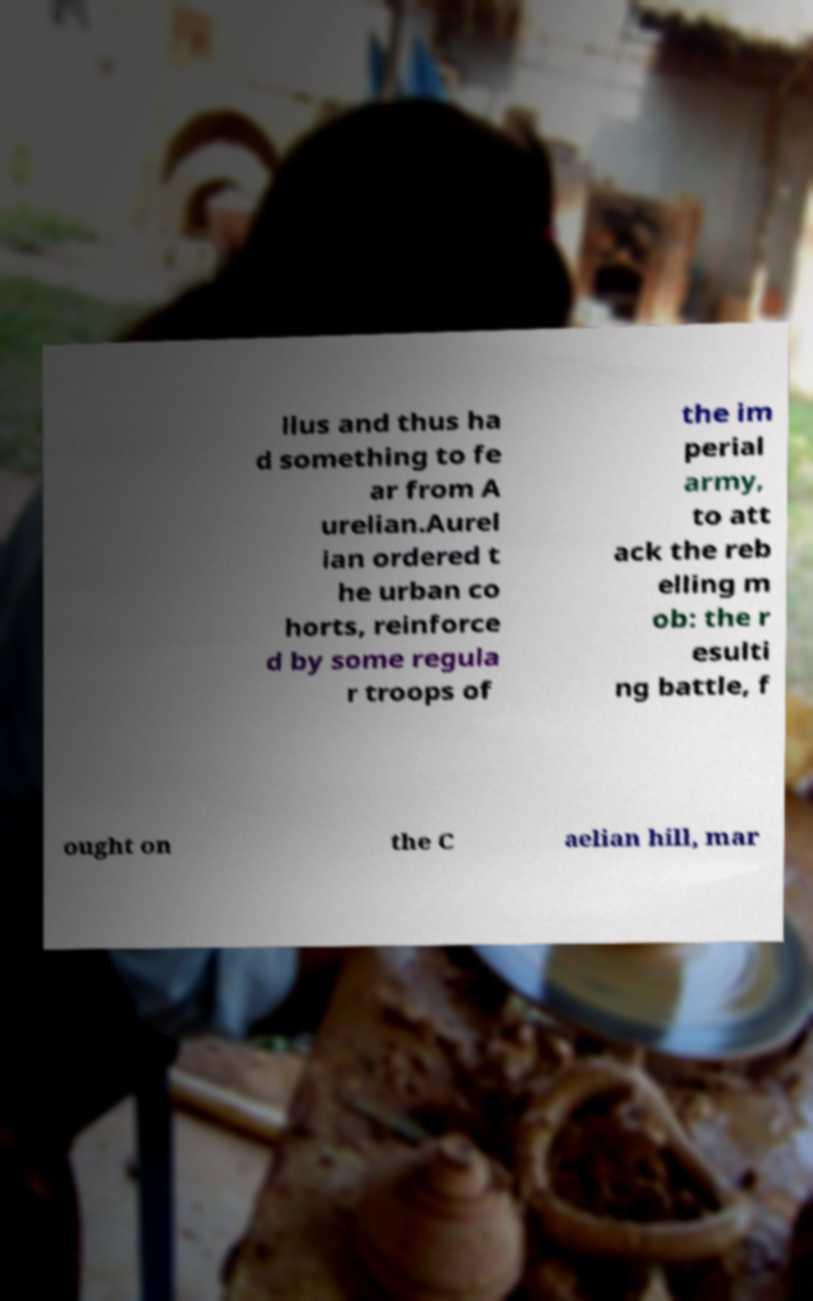Can you read and provide the text displayed in the image?This photo seems to have some interesting text. Can you extract and type it out for me? llus and thus ha d something to fe ar from A urelian.Aurel ian ordered t he urban co horts, reinforce d by some regula r troops of the im perial army, to att ack the reb elling m ob: the r esulti ng battle, f ought on the C aelian hill, mar 